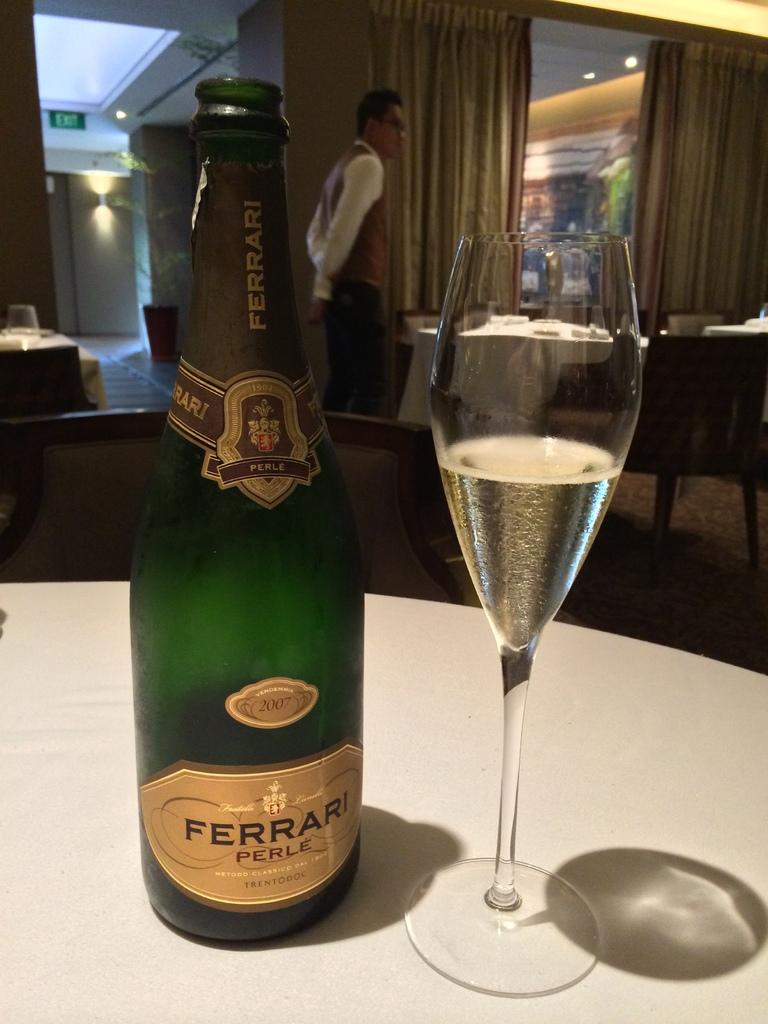What can be seen on the table in the image? There is a bottle and a glass on the table in the image. Where is the table located in the image? The table is in the center of the image. What is happening in the background of the image? There is a man walking in the background of the image. What type of setting is depicted in the image? The image depicts a restaurant setting with tables and chairs. What type of grain is being harvested in the image? There is no grain or harvesting activity present in the image. How much change is on the table in the image? There is no mention of change or money in the image; it features a bottle, a glass, and a table in a restaurant setting. 